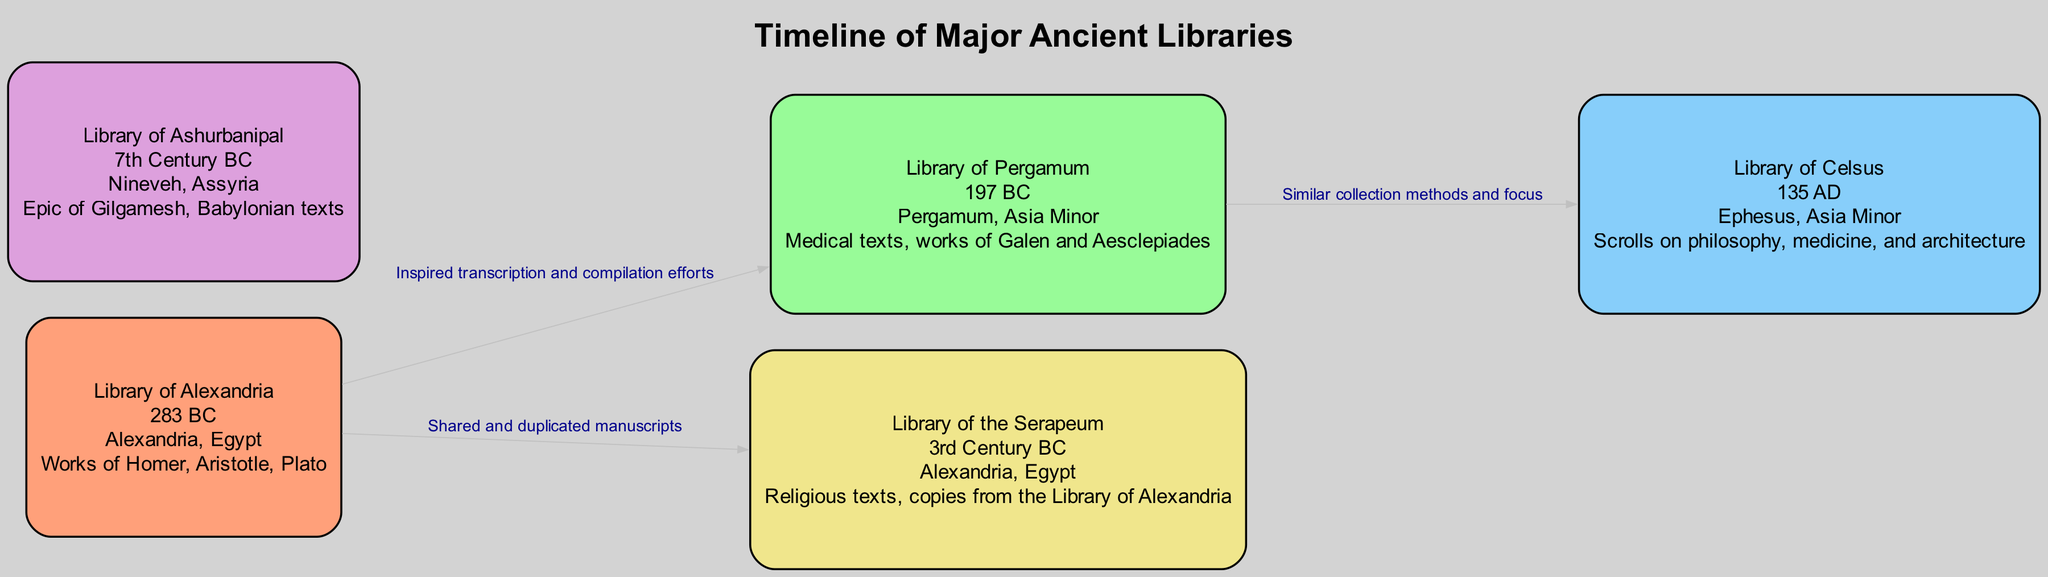What is the founding date of the Library of Alexandria? The diagram lists the founding date of the Library of Alexandria as 283 BC. This can be found in the node labeled "Library of Alexandria."
Answer: 283 BC How many libraries are represented in the diagram? The diagram includes a total of five nodes, each representing a different library. By counting the nodes listed, it is clear that there are five libraries depicted.
Answer: 5 What collections are associated with the Library of Pergamum? The diagram specifies that the Library of Pergamum contains medical texts, works of Galen and Aesclepiades. This information is included in the node for the Library of Pergamum.
Answer: Medical texts, works of Galen and Aesclepiades Which two libraries have a direct relationship in the diagram? The diagram shows edges connecting multiple libraries. The direct relationships identified include one between the Library of Alexandria and the Library of Pergamum, as well as one between the Library of Alexandria and the Library of the Serapeum.
Answer: Library of Alexandria and Library of Pergamum What is shared between the Library of Alexandria and the Library of the Serapeum? The edge between these two libraries indicates a relationship of shared and duplicated manuscripts. This is a direct connection noted in the edge's description.
Answer: Shared and duplicated manuscripts Which library is associated with the Epic of Gilgamesh? The diagram indicates that the Library of Ashurbanipal has collections that include the Epic of Gilgamesh. This is specified within the information for the Library of Ashurbanipal.
Answer: Library of Ashurbanipal What location is the Library of Celsus found in? The node for the Library of Celsus specifically states that it is located in Ephesus, Asia Minor. This information is clearly outlined in the respective node.
Answer: Ephesus, Asia Minor Which library's founding date is closest to the 1st century AD? Within the diagram, the Library of Celsus has a founding date of 135 AD, which is the only library in the diagram founded during the 1st century AD period. Thus, it is the closest founding date to that century.
Answer: Library of Celsus What relationship did the Library of Pergamum have with the Library of Celsus? The diagram shows that the Library of Pergamum and the Library of Celsus have a relationship centered on similar collection methods and focus. This detail is provided in the edge between them.
Answer: Similar collection methods and focus 